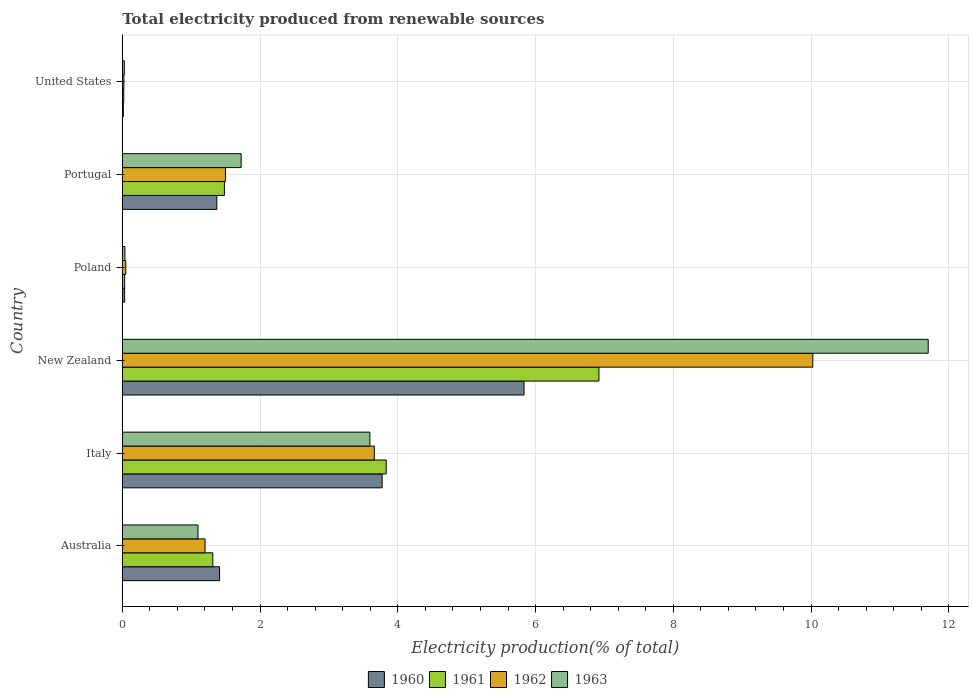How many groups of bars are there?
Offer a terse response. 6. Are the number of bars per tick equal to the number of legend labels?
Your answer should be very brief. Yes. Are the number of bars on each tick of the Y-axis equal?
Provide a short and direct response. Yes. How many bars are there on the 2nd tick from the top?
Your answer should be very brief. 4. In how many cases, is the number of bars for a given country not equal to the number of legend labels?
Your answer should be compact. 0. What is the total electricity produced in 1963 in Italy?
Provide a succinct answer. 3.59. Across all countries, what is the maximum total electricity produced in 1961?
Give a very brief answer. 6.92. Across all countries, what is the minimum total electricity produced in 1963?
Your answer should be very brief. 0.03. In which country was the total electricity produced in 1960 maximum?
Provide a succinct answer. New Zealand. In which country was the total electricity produced in 1960 minimum?
Ensure brevity in your answer.  United States. What is the total total electricity produced in 1963 in the graph?
Your response must be concise. 18.19. What is the difference between the total electricity produced in 1960 in New Zealand and that in Portugal?
Ensure brevity in your answer.  4.46. What is the difference between the total electricity produced in 1962 in Portugal and the total electricity produced in 1960 in New Zealand?
Keep it short and to the point. -4.33. What is the average total electricity produced in 1963 per country?
Your response must be concise. 3.03. What is the difference between the total electricity produced in 1960 and total electricity produced in 1961 in Portugal?
Provide a succinct answer. -0.11. In how many countries, is the total electricity produced in 1963 greater than 1.6 %?
Make the answer very short. 3. What is the ratio of the total electricity produced in 1961 in Australia to that in Poland?
Your answer should be compact. 38.51. Is the total electricity produced in 1961 in Australia less than that in New Zealand?
Your answer should be compact. Yes. What is the difference between the highest and the second highest total electricity produced in 1960?
Give a very brief answer. 2.06. What is the difference between the highest and the lowest total electricity produced in 1961?
Offer a very short reply. 6.9. In how many countries, is the total electricity produced in 1960 greater than the average total electricity produced in 1960 taken over all countries?
Your response must be concise. 2. Is it the case that in every country, the sum of the total electricity produced in 1961 and total electricity produced in 1962 is greater than the sum of total electricity produced in 1963 and total electricity produced in 1960?
Ensure brevity in your answer.  No. What does the 1st bar from the bottom in United States represents?
Your response must be concise. 1960. Is it the case that in every country, the sum of the total electricity produced in 1961 and total electricity produced in 1963 is greater than the total electricity produced in 1962?
Make the answer very short. Yes. What is the difference between two consecutive major ticks on the X-axis?
Provide a succinct answer. 2. Are the values on the major ticks of X-axis written in scientific E-notation?
Ensure brevity in your answer.  No. Does the graph contain any zero values?
Ensure brevity in your answer.  No. Where does the legend appear in the graph?
Keep it short and to the point. Bottom center. How many legend labels are there?
Offer a very short reply. 4. How are the legend labels stacked?
Make the answer very short. Horizontal. What is the title of the graph?
Provide a short and direct response. Total electricity produced from renewable sources. What is the Electricity production(% of total) of 1960 in Australia?
Offer a terse response. 1.41. What is the Electricity production(% of total) of 1961 in Australia?
Offer a very short reply. 1.31. What is the Electricity production(% of total) in 1962 in Australia?
Keep it short and to the point. 1.2. What is the Electricity production(% of total) of 1963 in Australia?
Offer a terse response. 1.1. What is the Electricity production(% of total) in 1960 in Italy?
Your response must be concise. 3.77. What is the Electricity production(% of total) in 1961 in Italy?
Provide a succinct answer. 3.83. What is the Electricity production(% of total) in 1962 in Italy?
Your answer should be compact. 3.66. What is the Electricity production(% of total) in 1963 in Italy?
Make the answer very short. 3.59. What is the Electricity production(% of total) in 1960 in New Zealand?
Keep it short and to the point. 5.83. What is the Electricity production(% of total) of 1961 in New Zealand?
Your answer should be compact. 6.92. What is the Electricity production(% of total) of 1962 in New Zealand?
Provide a short and direct response. 10.02. What is the Electricity production(% of total) in 1963 in New Zealand?
Ensure brevity in your answer.  11.7. What is the Electricity production(% of total) in 1960 in Poland?
Keep it short and to the point. 0.03. What is the Electricity production(% of total) of 1961 in Poland?
Keep it short and to the point. 0.03. What is the Electricity production(% of total) in 1962 in Poland?
Your answer should be compact. 0.05. What is the Electricity production(% of total) of 1963 in Poland?
Make the answer very short. 0.04. What is the Electricity production(% of total) in 1960 in Portugal?
Your answer should be very brief. 1.37. What is the Electricity production(% of total) in 1961 in Portugal?
Give a very brief answer. 1.48. What is the Electricity production(% of total) in 1962 in Portugal?
Provide a succinct answer. 1.5. What is the Electricity production(% of total) in 1963 in Portugal?
Make the answer very short. 1.73. What is the Electricity production(% of total) in 1960 in United States?
Keep it short and to the point. 0.02. What is the Electricity production(% of total) of 1961 in United States?
Make the answer very short. 0.02. What is the Electricity production(% of total) of 1962 in United States?
Make the answer very short. 0.02. What is the Electricity production(% of total) in 1963 in United States?
Provide a succinct answer. 0.03. Across all countries, what is the maximum Electricity production(% of total) in 1960?
Your response must be concise. 5.83. Across all countries, what is the maximum Electricity production(% of total) of 1961?
Give a very brief answer. 6.92. Across all countries, what is the maximum Electricity production(% of total) in 1962?
Your answer should be very brief. 10.02. Across all countries, what is the maximum Electricity production(% of total) of 1963?
Keep it short and to the point. 11.7. Across all countries, what is the minimum Electricity production(% of total) in 1960?
Provide a short and direct response. 0.02. Across all countries, what is the minimum Electricity production(% of total) in 1961?
Keep it short and to the point. 0.02. Across all countries, what is the minimum Electricity production(% of total) in 1962?
Offer a terse response. 0.02. Across all countries, what is the minimum Electricity production(% of total) of 1963?
Give a very brief answer. 0.03. What is the total Electricity production(% of total) of 1960 in the graph?
Offer a terse response. 12.44. What is the total Electricity production(% of total) in 1961 in the graph?
Make the answer very short. 13.6. What is the total Electricity production(% of total) of 1962 in the graph?
Your answer should be very brief. 16.46. What is the total Electricity production(% of total) in 1963 in the graph?
Keep it short and to the point. 18.19. What is the difference between the Electricity production(% of total) of 1960 in Australia and that in Italy?
Give a very brief answer. -2.36. What is the difference between the Electricity production(% of total) in 1961 in Australia and that in Italy?
Provide a short and direct response. -2.52. What is the difference between the Electricity production(% of total) of 1962 in Australia and that in Italy?
Your answer should be compact. -2.46. What is the difference between the Electricity production(% of total) in 1963 in Australia and that in Italy?
Provide a succinct answer. -2.5. What is the difference between the Electricity production(% of total) in 1960 in Australia and that in New Zealand?
Give a very brief answer. -4.42. What is the difference between the Electricity production(% of total) in 1961 in Australia and that in New Zealand?
Ensure brevity in your answer.  -5.61. What is the difference between the Electricity production(% of total) in 1962 in Australia and that in New Zealand?
Your answer should be very brief. -8.82. What is the difference between the Electricity production(% of total) of 1963 in Australia and that in New Zealand?
Your answer should be very brief. -10.6. What is the difference between the Electricity production(% of total) in 1960 in Australia and that in Poland?
Offer a terse response. 1.38. What is the difference between the Electricity production(% of total) in 1961 in Australia and that in Poland?
Ensure brevity in your answer.  1.28. What is the difference between the Electricity production(% of total) of 1962 in Australia and that in Poland?
Your answer should be very brief. 1.15. What is the difference between the Electricity production(% of total) in 1963 in Australia and that in Poland?
Offer a very short reply. 1.06. What is the difference between the Electricity production(% of total) in 1960 in Australia and that in Portugal?
Make the answer very short. 0.04. What is the difference between the Electricity production(% of total) of 1961 in Australia and that in Portugal?
Offer a very short reply. -0.17. What is the difference between the Electricity production(% of total) in 1962 in Australia and that in Portugal?
Provide a short and direct response. -0.3. What is the difference between the Electricity production(% of total) of 1963 in Australia and that in Portugal?
Ensure brevity in your answer.  -0.63. What is the difference between the Electricity production(% of total) in 1960 in Australia and that in United States?
Your answer should be compact. 1.4. What is the difference between the Electricity production(% of total) of 1961 in Australia and that in United States?
Your answer should be compact. 1.29. What is the difference between the Electricity production(% of total) in 1962 in Australia and that in United States?
Your answer should be compact. 1.18. What is the difference between the Electricity production(% of total) in 1963 in Australia and that in United States?
Provide a succinct answer. 1.07. What is the difference between the Electricity production(% of total) of 1960 in Italy and that in New Zealand?
Ensure brevity in your answer.  -2.06. What is the difference between the Electricity production(% of total) in 1961 in Italy and that in New Zealand?
Ensure brevity in your answer.  -3.09. What is the difference between the Electricity production(% of total) of 1962 in Italy and that in New Zealand?
Make the answer very short. -6.37. What is the difference between the Electricity production(% of total) of 1963 in Italy and that in New Zealand?
Make the answer very short. -8.11. What is the difference between the Electricity production(% of total) of 1960 in Italy and that in Poland?
Your response must be concise. 3.74. What is the difference between the Electricity production(% of total) in 1961 in Italy and that in Poland?
Keep it short and to the point. 3.8. What is the difference between the Electricity production(% of total) of 1962 in Italy and that in Poland?
Keep it short and to the point. 3.61. What is the difference between the Electricity production(% of total) of 1963 in Italy and that in Poland?
Provide a short and direct response. 3.56. What is the difference between the Electricity production(% of total) of 1960 in Italy and that in Portugal?
Ensure brevity in your answer.  2.4. What is the difference between the Electricity production(% of total) of 1961 in Italy and that in Portugal?
Provide a succinct answer. 2.35. What is the difference between the Electricity production(% of total) in 1962 in Italy and that in Portugal?
Offer a very short reply. 2.16. What is the difference between the Electricity production(% of total) of 1963 in Italy and that in Portugal?
Ensure brevity in your answer.  1.87. What is the difference between the Electricity production(% of total) in 1960 in Italy and that in United States?
Provide a succinct answer. 3.76. What is the difference between the Electricity production(% of total) of 1961 in Italy and that in United States?
Make the answer very short. 3.81. What is the difference between the Electricity production(% of total) in 1962 in Italy and that in United States?
Keep it short and to the point. 3.64. What is the difference between the Electricity production(% of total) of 1963 in Italy and that in United States?
Ensure brevity in your answer.  3.56. What is the difference between the Electricity production(% of total) of 1960 in New Zealand and that in Poland?
Keep it short and to the point. 5.8. What is the difference between the Electricity production(% of total) in 1961 in New Zealand and that in Poland?
Offer a very short reply. 6.89. What is the difference between the Electricity production(% of total) in 1962 in New Zealand and that in Poland?
Provide a succinct answer. 9.97. What is the difference between the Electricity production(% of total) of 1963 in New Zealand and that in Poland?
Your response must be concise. 11.66. What is the difference between the Electricity production(% of total) of 1960 in New Zealand and that in Portugal?
Your response must be concise. 4.46. What is the difference between the Electricity production(% of total) in 1961 in New Zealand and that in Portugal?
Make the answer very short. 5.44. What is the difference between the Electricity production(% of total) of 1962 in New Zealand and that in Portugal?
Offer a very short reply. 8.53. What is the difference between the Electricity production(% of total) in 1963 in New Zealand and that in Portugal?
Give a very brief answer. 9.97. What is the difference between the Electricity production(% of total) in 1960 in New Zealand and that in United States?
Provide a succinct answer. 5.82. What is the difference between the Electricity production(% of total) of 1961 in New Zealand and that in United States?
Ensure brevity in your answer.  6.9. What is the difference between the Electricity production(% of total) in 1962 in New Zealand and that in United States?
Your response must be concise. 10. What is the difference between the Electricity production(% of total) of 1963 in New Zealand and that in United States?
Offer a terse response. 11.67. What is the difference between the Electricity production(% of total) in 1960 in Poland and that in Portugal?
Make the answer very short. -1.34. What is the difference between the Electricity production(% of total) in 1961 in Poland and that in Portugal?
Provide a short and direct response. -1.45. What is the difference between the Electricity production(% of total) of 1962 in Poland and that in Portugal?
Keep it short and to the point. -1.45. What is the difference between the Electricity production(% of total) of 1963 in Poland and that in Portugal?
Your answer should be compact. -1.69. What is the difference between the Electricity production(% of total) of 1960 in Poland and that in United States?
Offer a terse response. 0.02. What is the difference between the Electricity production(% of total) in 1961 in Poland and that in United States?
Make the answer very short. 0.01. What is the difference between the Electricity production(% of total) of 1962 in Poland and that in United States?
Provide a succinct answer. 0.03. What is the difference between the Electricity production(% of total) of 1963 in Poland and that in United States?
Your answer should be compact. 0.01. What is the difference between the Electricity production(% of total) of 1960 in Portugal and that in United States?
Offer a very short reply. 1.36. What is the difference between the Electricity production(% of total) of 1961 in Portugal and that in United States?
Your answer should be compact. 1.46. What is the difference between the Electricity production(% of total) of 1962 in Portugal and that in United States?
Offer a terse response. 1.48. What is the difference between the Electricity production(% of total) in 1963 in Portugal and that in United States?
Make the answer very short. 1.7. What is the difference between the Electricity production(% of total) in 1960 in Australia and the Electricity production(% of total) in 1961 in Italy?
Provide a succinct answer. -2.42. What is the difference between the Electricity production(% of total) of 1960 in Australia and the Electricity production(% of total) of 1962 in Italy?
Provide a short and direct response. -2.25. What is the difference between the Electricity production(% of total) of 1960 in Australia and the Electricity production(% of total) of 1963 in Italy?
Your answer should be compact. -2.18. What is the difference between the Electricity production(% of total) of 1961 in Australia and the Electricity production(% of total) of 1962 in Italy?
Your response must be concise. -2.34. What is the difference between the Electricity production(% of total) in 1961 in Australia and the Electricity production(% of total) in 1963 in Italy?
Your answer should be compact. -2.28. What is the difference between the Electricity production(% of total) in 1962 in Australia and the Electricity production(% of total) in 1963 in Italy?
Your answer should be very brief. -2.39. What is the difference between the Electricity production(% of total) in 1960 in Australia and the Electricity production(% of total) in 1961 in New Zealand?
Offer a very short reply. -5.51. What is the difference between the Electricity production(% of total) in 1960 in Australia and the Electricity production(% of total) in 1962 in New Zealand?
Give a very brief answer. -8.61. What is the difference between the Electricity production(% of total) of 1960 in Australia and the Electricity production(% of total) of 1963 in New Zealand?
Offer a terse response. -10.29. What is the difference between the Electricity production(% of total) in 1961 in Australia and the Electricity production(% of total) in 1962 in New Zealand?
Offer a very short reply. -8.71. What is the difference between the Electricity production(% of total) of 1961 in Australia and the Electricity production(% of total) of 1963 in New Zealand?
Give a very brief answer. -10.39. What is the difference between the Electricity production(% of total) of 1962 in Australia and the Electricity production(% of total) of 1963 in New Zealand?
Provide a succinct answer. -10.5. What is the difference between the Electricity production(% of total) in 1960 in Australia and the Electricity production(% of total) in 1961 in Poland?
Provide a succinct answer. 1.38. What is the difference between the Electricity production(% of total) in 1960 in Australia and the Electricity production(% of total) in 1962 in Poland?
Provide a succinct answer. 1.36. What is the difference between the Electricity production(% of total) of 1960 in Australia and the Electricity production(% of total) of 1963 in Poland?
Provide a succinct answer. 1.37. What is the difference between the Electricity production(% of total) in 1961 in Australia and the Electricity production(% of total) in 1962 in Poland?
Give a very brief answer. 1.26. What is the difference between the Electricity production(% of total) of 1961 in Australia and the Electricity production(% of total) of 1963 in Poland?
Your answer should be very brief. 1.28. What is the difference between the Electricity production(% of total) of 1962 in Australia and the Electricity production(% of total) of 1963 in Poland?
Offer a terse response. 1.16. What is the difference between the Electricity production(% of total) in 1960 in Australia and the Electricity production(% of total) in 1961 in Portugal?
Offer a very short reply. -0.07. What is the difference between the Electricity production(% of total) in 1960 in Australia and the Electricity production(% of total) in 1962 in Portugal?
Keep it short and to the point. -0.09. What is the difference between the Electricity production(% of total) of 1960 in Australia and the Electricity production(% of total) of 1963 in Portugal?
Keep it short and to the point. -0.31. What is the difference between the Electricity production(% of total) of 1961 in Australia and the Electricity production(% of total) of 1962 in Portugal?
Offer a terse response. -0.18. What is the difference between the Electricity production(% of total) of 1961 in Australia and the Electricity production(% of total) of 1963 in Portugal?
Your answer should be very brief. -0.41. What is the difference between the Electricity production(% of total) in 1962 in Australia and the Electricity production(% of total) in 1963 in Portugal?
Offer a terse response. -0.52. What is the difference between the Electricity production(% of total) in 1960 in Australia and the Electricity production(% of total) in 1961 in United States?
Keep it short and to the point. 1.39. What is the difference between the Electricity production(% of total) in 1960 in Australia and the Electricity production(% of total) in 1962 in United States?
Offer a terse response. 1.39. What is the difference between the Electricity production(% of total) of 1960 in Australia and the Electricity production(% of total) of 1963 in United States?
Your answer should be compact. 1.38. What is the difference between the Electricity production(% of total) in 1961 in Australia and the Electricity production(% of total) in 1962 in United States?
Keep it short and to the point. 1.29. What is the difference between the Electricity production(% of total) of 1961 in Australia and the Electricity production(% of total) of 1963 in United States?
Make the answer very short. 1.28. What is the difference between the Electricity production(% of total) of 1962 in Australia and the Electricity production(% of total) of 1963 in United States?
Provide a short and direct response. 1.17. What is the difference between the Electricity production(% of total) of 1960 in Italy and the Electricity production(% of total) of 1961 in New Zealand?
Offer a terse response. -3.15. What is the difference between the Electricity production(% of total) in 1960 in Italy and the Electricity production(% of total) in 1962 in New Zealand?
Provide a succinct answer. -6.25. What is the difference between the Electricity production(% of total) in 1960 in Italy and the Electricity production(% of total) in 1963 in New Zealand?
Offer a very short reply. -7.93. What is the difference between the Electricity production(% of total) of 1961 in Italy and the Electricity production(% of total) of 1962 in New Zealand?
Your answer should be compact. -6.19. What is the difference between the Electricity production(% of total) of 1961 in Italy and the Electricity production(% of total) of 1963 in New Zealand?
Provide a succinct answer. -7.87. What is the difference between the Electricity production(% of total) in 1962 in Italy and the Electricity production(% of total) in 1963 in New Zealand?
Give a very brief answer. -8.04. What is the difference between the Electricity production(% of total) in 1960 in Italy and the Electricity production(% of total) in 1961 in Poland?
Make the answer very short. 3.74. What is the difference between the Electricity production(% of total) of 1960 in Italy and the Electricity production(% of total) of 1962 in Poland?
Ensure brevity in your answer.  3.72. What is the difference between the Electricity production(% of total) of 1960 in Italy and the Electricity production(% of total) of 1963 in Poland?
Offer a very short reply. 3.73. What is the difference between the Electricity production(% of total) in 1961 in Italy and the Electricity production(% of total) in 1962 in Poland?
Make the answer very short. 3.78. What is the difference between the Electricity production(% of total) of 1961 in Italy and the Electricity production(% of total) of 1963 in Poland?
Your answer should be very brief. 3.79. What is the difference between the Electricity production(% of total) in 1962 in Italy and the Electricity production(% of total) in 1963 in Poland?
Ensure brevity in your answer.  3.62. What is the difference between the Electricity production(% of total) of 1960 in Italy and the Electricity production(% of total) of 1961 in Portugal?
Ensure brevity in your answer.  2.29. What is the difference between the Electricity production(% of total) of 1960 in Italy and the Electricity production(% of total) of 1962 in Portugal?
Your response must be concise. 2.27. What is the difference between the Electricity production(% of total) in 1960 in Italy and the Electricity production(% of total) in 1963 in Portugal?
Keep it short and to the point. 2.05. What is the difference between the Electricity production(% of total) of 1961 in Italy and the Electricity production(% of total) of 1962 in Portugal?
Your answer should be very brief. 2.33. What is the difference between the Electricity production(% of total) of 1961 in Italy and the Electricity production(% of total) of 1963 in Portugal?
Ensure brevity in your answer.  2.11. What is the difference between the Electricity production(% of total) of 1962 in Italy and the Electricity production(% of total) of 1963 in Portugal?
Give a very brief answer. 1.93. What is the difference between the Electricity production(% of total) in 1960 in Italy and the Electricity production(% of total) in 1961 in United States?
Keep it short and to the point. 3.75. What is the difference between the Electricity production(% of total) in 1960 in Italy and the Electricity production(% of total) in 1962 in United States?
Ensure brevity in your answer.  3.75. What is the difference between the Electricity production(% of total) of 1960 in Italy and the Electricity production(% of total) of 1963 in United States?
Keep it short and to the point. 3.74. What is the difference between the Electricity production(% of total) of 1961 in Italy and the Electricity production(% of total) of 1962 in United States?
Ensure brevity in your answer.  3.81. What is the difference between the Electricity production(% of total) in 1961 in Italy and the Electricity production(% of total) in 1963 in United States?
Keep it short and to the point. 3.8. What is the difference between the Electricity production(% of total) in 1962 in Italy and the Electricity production(% of total) in 1963 in United States?
Offer a terse response. 3.63. What is the difference between the Electricity production(% of total) in 1960 in New Zealand and the Electricity production(% of total) in 1961 in Poland?
Your answer should be very brief. 5.8. What is the difference between the Electricity production(% of total) in 1960 in New Zealand and the Electricity production(% of total) in 1962 in Poland?
Offer a terse response. 5.78. What is the difference between the Electricity production(% of total) in 1960 in New Zealand and the Electricity production(% of total) in 1963 in Poland?
Provide a succinct answer. 5.79. What is the difference between the Electricity production(% of total) of 1961 in New Zealand and the Electricity production(% of total) of 1962 in Poland?
Your answer should be very brief. 6.87. What is the difference between the Electricity production(% of total) of 1961 in New Zealand and the Electricity production(% of total) of 1963 in Poland?
Your response must be concise. 6.88. What is the difference between the Electricity production(% of total) of 1962 in New Zealand and the Electricity production(% of total) of 1963 in Poland?
Keep it short and to the point. 9.99. What is the difference between the Electricity production(% of total) of 1960 in New Zealand and the Electricity production(% of total) of 1961 in Portugal?
Make the answer very short. 4.35. What is the difference between the Electricity production(% of total) in 1960 in New Zealand and the Electricity production(% of total) in 1962 in Portugal?
Your answer should be compact. 4.33. What is the difference between the Electricity production(% of total) in 1960 in New Zealand and the Electricity production(% of total) in 1963 in Portugal?
Provide a short and direct response. 4.11. What is the difference between the Electricity production(% of total) of 1961 in New Zealand and the Electricity production(% of total) of 1962 in Portugal?
Make the answer very short. 5.42. What is the difference between the Electricity production(% of total) in 1961 in New Zealand and the Electricity production(% of total) in 1963 in Portugal?
Offer a terse response. 5.19. What is the difference between the Electricity production(% of total) in 1962 in New Zealand and the Electricity production(% of total) in 1963 in Portugal?
Your answer should be compact. 8.3. What is the difference between the Electricity production(% of total) in 1960 in New Zealand and the Electricity production(% of total) in 1961 in United States?
Your answer should be very brief. 5.81. What is the difference between the Electricity production(% of total) in 1960 in New Zealand and the Electricity production(% of total) in 1962 in United States?
Offer a terse response. 5.81. What is the difference between the Electricity production(% of total) in 1960 in New Zealand and the Electricity production(% of total) in 1963 in United States?
Give a very brief answer. 5.8. What is the difference between the Electricity production(% of total) in 1961 in New Zealand and the Electricity production(% of total) in 1962 in United States?
Give a very brief answer. 6.9. What is the difference between the Electricity production(% of total) in 1961 in New Zealand and the Electricity production(% of total) in 1963 in United States?
Provide a succinct answer. 6.89. What is the difference between the Electricity production(% of total) of 1962 in New Zealand and the Electricity production(% of total) of 1963 in United States?
Give a very brief answer. 10. What is the difference between the Electricity production(% of total) in 1960 in Poland and the Electricity production(% of total) in 1961 in Portugal?
Keep it short and to the point. -1.45. What is the difference between the Electricity production(% of total) in 1960 in Poland and the Electricity production(% of total) in 1962 in Portugal?
Your response must be concise. -1.46. What is the difference between the Electricity production(% of total) of 1960 in Poland and the Electricity production(% of total) of 1963 in Portugal?
Your answer should be very brief. -1.69. What is the difference between the Electricity production(% of total) in 1961 in Poland and the Electricity production(% of total) in 1962 in Portugal?
Make the answer very short. -1.46. What is the difference between the Electricity production(% of total) in 1961 in Poland and the Electricity production(% of total) in 1963 in Portugal?
Offer a very short reply. -1.69. What is the difference between the Electricity production(% of total) of 1962 in Poland and the Electricity production(% of total) of 1963 in Portugal?
Provide a succinct answer. -1.67. What is the difference between the Electricity production(% of total) in 1960 in Poland and the Electricity production(% of total) in 1961 in United States?
Provide a short and direct response. 0.01. What is the difference between the Electricity production(% of total) of 1960 in Poland and the Electricity production(% of total) of 1962 in United States?
Keep it short and to the point. 0.01. What is the difference between the Electricity production(% of total) of 1960 in Poland and the Electricity production(% of total) of 1963 in United States?
Provide a short and direct response. 0. What is the difference between the Electricity production(% of total) of 1961 in Poland and the Electricity production(% of total) of 1962 in United States?
Ensure brevity in your answer.  0.01. What is the difference between the Electricity production(% of total) of 1961 in Poland and the Electricity production(% of total) of 1963 in United States?
Offer a very short reply. 0. What is the difference between the Electricity production(% of total) in 1962 in Poland and the Electricity production(% of total) in 1963 in United States?
Offer a terse response. 0.02. What is the difference between the Electricity production(% of total) of 1960 in Portugal and the Electricity production(% of total) of 1961 in United States?
Your answer should be very brief. 1.35. What is the difference between the Electricity production(% of total) of 1960 in Portugal and the Electricity production(% of total) of 1962 in United States?
Your response must be concise. 1.35. What is the difference between the Electricity production(% of total) in 1960 in Portugal and the Electricity production(% of total) in 1963 in United States?
Your response must be concise. 1.34. What is the difference between the Electricity production(% of total) of 1961 in Portugal and the Electricity production(% of total) of 1962 in United States?
Keep it short and to the point. 1.46. What is the difference between the Electricity production(% of total) in 1961 in Portugal and the Electricity production(% of total) in 1963 in United States?
Keep it short and to the point. 1.45. What is the difference between the Electricity production(% of total) in 1962 in Portugal and the Electricity production(% of total) in 1963 in United States?
Provide a succinct answer. 1.47. What is the average Electricity production(% of total) in 1960 per country?
Provide a succinct answer. 2.07. What is the average Electricity production(% of total) of 1961 per country?
Give a very brief answer. 2.27. What is the average Electricity production(% of total) in 1962 per country?
Your answer should be compact. 2.74. What is the average Electricity production(% of total) of 1963 per country?
Offer a terse response. 3.03. What is the difference between the Electricity production(% of total) of 1960 and Electricity production(% of total) of 1961 in Australia?
Your response must be concise. 0.1. What is the difference between the Electricity production(% of total) of 1960 and Electricity production(% of total) of 1962 in Australia?
Give a very brief answer. 0.21. What is the difference between the Electricity production(% of total) in 1960 and Electricity production(% of total) in 1963 in Australia?
Provide a short and direct response. 0.31. What is the difference between the Electricity production(% of total) in 1961 and Electricity production(% of total) in 1962 in Australia?
Your response must be concise. 0.11. What is the difference between the Electricity production(% of total) of 1961 and Electricity production(% of total) of 1963 in Australia?
Your answer should be compact. 0.21. What is the difference between the Electricity production(% of total) of 1962 and Electricity production(% of total) of 1963 in Australia?
Make the answer very short. 0.1. What is the difference between the Electricity production(% of total) in 1960 and Electricity production(% of total) in 1961 in Italy?
Offer a very short reply. -0.06. What is the difference between the Electricity production(% of total) of 1960 and Electricity production(% of total) of 1962 in Italy?
Give a very brief answer. 0.11. What is the difference between the Electricity production(% of total) of 1960 and Electricity production(% of total) of 1963 in Italy?
Ensure brevity in your answer.  0.18. What is the difference between the Electricity production(% of total) of 1961 and Electricity production(% of total) of 1962 in Italy?
Keep it short and to the point. 0.17. What is the difference between the Electricity production(% of total) of 1961 and Electricity production(% of total) of 1963 in Italy?
Keep it short and to the point. 0.24. What is the difference between the Electricity production(% of total) of 1962 and Electricity production(% of total) of 1963 in Italy?
Offer a terse response. 0.06. What is the difference between the Electricity production(% of total) of 1960 and Electricity production(% of total) of 1961 in New Zealand?
Make the answer very short. -1.09. What is the difference between the Electricity production(% of total) of 1960 and Electricity production(% of total) of 1962 in New Zealand?
Your response must be concise. -4.19. What is the difference between the Electricity production(% of total) of 1960 and Electricity production(% of total) of 1963 in New Zealand?
Give a very brief answer. -5.87. What is the difference between the Electricity production(% of total) in 1961 and Electricity production(% of total) in 1962 in New Zealand?
Provide a succinct answer. -3.1. What is the difference between the Electricity production(% of total) of 1961 and Electricity production(% of total) of 1963 in New Zealand?
Provide a succinct answer. -4.78. What is the difference between the Electricity production(% of total) in 1962 and Electricity production(% of total) in 1963 in New Zealand?
Your response must be concise. -1.68. What is the difference between the Electricity production(% of total) of 1960 and Electricity production(% of total) of 1962 in Poland?
Your response must be concise. -0.02. What is the difference between the Electricity production(% of total) of 1960 and Electricity production(% of total) of 1963 in Poland?
Give a very brief answer. -0. What is the difference between the Electricity production(% of total) in 1961 and Electricity production(% of total) in 1962 in Poland?
Provide a short and direct response. -0.02. What is the difference between the Electricity production(% of total) in 1961 and Electricity production(% of total) in 1963 in Poland?
Provide a short and direct response. -0. What is the difference between the Electricity production(% of total) of 1962 and Electricity production(% of total) of 1963 in Poland?
Ensure brevity in your answer.  0.01. What is the difference between the Electricity production(% of total) of 1960 and Electricity production(% of total) of 1961 in Portugal?
Provide a short and direct response. -0.11. What is the difference between the Electricity production(% of total) of 1960 and Electricity production(% of total) of 1962 in Portugal?
Offer a terse response. -0.13. What is the difference between the Electricity production(% of total) of 1960 and Electricity production(% of total) of 1963 in Portugal?
Make the answer very short. -0.35. What is the difference between the Electricity production(% of total) of 1961 and Electricity production(% of total) of 1962 in Portugal?
Make the answer very short. -0.02. What is the difference between the Electricity production(% of total) in 1961 and Electricity production(% of total) in 1963 in Portugal?
Provide a short and direct response. -0.24. What is the difference between the Electricity production(% of total) of 1962 and Electricity production(% of total) of 1963 in Portugal?
Provide a short and direct response. -0.23. What is the difference between the Electricity production(% of total) of 1960 and Electricity production(% of total) of 1961 in United States?
Offer a terse response. -0.01. What is the difference between the Electricity production(% of total) of 1960 and Electricity production(% of total) of 1962 in United States?
Provide a short and direct response. -0.01. What is the difference between the Electricity production(% of total) of 1960 and Electricity production(% of total) of 1963 in United States?
Offer a very short reply. -0.01. What is the difference between the Electricity production(% of total) in 1961 and Electricity production(% of total) in 1962 in United States?
Offer a terse response. -0. What is the difference between the Electricity production(% of total) of 1961 and Electricity production(% of total) of 1963 in United States?
Make the answer very short. -0.01. What is the difference between the Electricity production(% of total) in 1962 and Electricity production(% of total) in 1963 in United States?
Keep it short and to the point. -0.01. What is the ratio of the Electricity production(% of total) of 1960 in Australia to that in Italy?
Ensure brevity in your answer.  0.37. What is the ratio of the Electricity production(% of total) of 1961 in Australia to that in Italy?
Your answer should be very brief. 0.34. What is the ratio of the Electricity production(% of total) in 1962 in Australia to that in Italy?
Provide a short and direct response. 0.33. What is the ratio of the Electricity production(% of total) of 1963 in Australia to that in Italy?
Offer a terse response. 0.31. What is the ratio of the Electricity production(% of total) of 1960 in Australia to that in New Zealand?
Your answer should be compact. 0.24. What is the ratio of the Electricity production(% of total) in 1961 in Australia to that in New Zealand?
Provide a short and direct response. 0.19. What is the ratio of the Electricity production(% of total) of 1962 in Australia to that in New Zealand?
Your answer should be very brief. 0.12. What is the ratio of the Electricity production(% of total) of 1963 in Australia to that in New Zealand?
Provide a short and direct response. 0.09. What is the ratio of the Electricity production(% of total) in 1960 in Australia to that in Poland?
Provide a succinct answer. 41.37. What is the ratio of the Electricity production(% of total) of 1961 in Australia to that in Poland?
Give a very brief answer. 38.51. What is the ratio of the Electricity production(% of total) of 1962 in Australia to that in Poland?
Make the answer very short. 23.61. What is the ratio of the Electricity production(% of total) in 1963 in Australia to that in Poland?
Your answer should be compact. 29. What is the ratio of the Electricity production(% of total) of 1960 in Australia to that in Portugal?
Give a very brief answer. 1.03. What is the ratio of the Electricity production(% of total) in 1961 in Australia to that in Portugal?
Your answer should be very brief. 0.89. What is the ratio of the Electricity production(% of total) of 1962 in Australia to that in Portugal?
Your response must be concise. 0.8. What is the ratio of the Electricity production(% of total) in 1963 in Australia to that in Portugal?
Provide a succinct answer. 0.64. What is the ratio of the Electricity production(% of total) of 1960 in Australia to that in United States?
Offer a terse response. 92.6. What is the ratio of the Electricity production(% of total) of 1961 in Australia to that in United States?
Ensure brevity in your answer.  61. What is the ratio of the Electricity production(% of total) in 1962 in Australia to that in United States?
Provide a short and direct response. 52.74. What is the ratio of the Electricity production(% of total) in 1963 in Australia to that in United States?
Keep it short and to the point. 37.34. What is the ratio of the Electricity production(% of total) in 1960 in Italy to that in New Zealand?
Offer a terse response. 0.65. What is the ratio of the Electricity production(% of total) of 1961 in Italy to that in New Zealand?
Your answer should be compact. 0.55. What is the ratio of the Electricity production(% of total) in 1962 in Italy to that in New Zealand?
Offer a very short reply. 0.36. What is the ratio of the Electricity production(% of total) in 1963 in Italy to that in New Zealand?
Your answer should be very brief. 0.31. What is the ratio of the Electricity production(% of total) of 1960 in Italy to that in Poland?
Your answer should be compact. 110.45. What is the ratio of the Electricity production(% of total) of 1961 in Italy to that in Poland?
Your response must be concise. 112.3. What is the ratio of the Electricity production(% of total) of 1962 in Italy to that in Poland?
Make the answer very short. 71.88. What is the ratio of the Electricity production(% of total) of 1963 in Italy to that in Poland?
Provide a succinct answer. 94.84. What is the ratio of the Electricity production(% of total) of 1960 in Italy to that in Portugal?
Offer a very short reply. 2.75. What is the ratio of the Electricity production(% of total) in 1961 in Italy to that in Portugal?
Provide a short and direct response. 2.58. What is the ratio of the Electricity production(% of total) of 1962 in Italy to that in Portugal?
Provide a short and direct response. 2.44. What is the ratio of the Electricity production(% of total) of 1963 in Italy to that in Portugal?
Your response must be concise. 2.08. What is the ratio of the Electricity production(% of total) of 1960 in Italy to that in United States?
Your answer should be very brief. 247.25. What is the ratio of the Electricity production(% of total) of 1961 in Italy to that in United States?
Your answer should be very brief. 177.87. What is the ratio of the Electricity production(% of total) in 1962 in Italy to that in United States?
Give a very brief answer. 160.56. What is the ratio of the Electricity production(% of total) in 1963 in Italy to that in United States?
Ensure brevity in your answer.  122.12. What is the ratio of the Electricity production(% of total) of 1960 in New Zealand to that in Poland?
Make the answer very short. 170.79. What is the ratio of the Electricity production(% of total) of 1961 in New Zealand to that in Poland?
Provide a short and direct response. 202.83. What is the ratio of the Electricity production(% of total) of 1962 in New Zealand to that in Poland?
Give a very brief answer. 196.95. What is the ratio of the Electricity production(% of total) in 1963 in New Zealand to that in Poland?
Your answer should be very brief. 308.73. What is the ratio of the Electricity production(% of total) in 1960 in New Zealand to that in Portugal?
Make the answer very short. 4.25. What is the ratio of the Electricity production(% of total) of 1961 in New Zealand to that in Portugal?
Your answer should be compact. 4.67. What is the ratio of the Electricity production(% of total) in 1962 in New Zealand to that in Portugal?
Provide a short and direct response. 6.69. What is the ratio of the Electricity production(% of total) in 1963 in New Zealand to that in Portugal?
Ensure brevity in your answer.  6.78. What is the ratio of the Electricity production(% of total) of 1960 in New Zealand to that in United States?
Your response must be concise. 382.31. What is the ratio of the Electricity production(% of total) in 1961 in New Zealand to that in United States?
Give a very brief answer. 321.25. What is the ratio of the Electricity production(% of total) of 1962 in New Zealand to that in United States?
Your answer should be compact. 439.93. What is the ratio of the Electricity production(% of total) in 1963 in New Zealand to that in United States?
Your response must be concise. 397.5. What is the ratio of the Electricity production(% of total) of 1960 in Poland to that in Portugal?
Your answer should be very brief. 0.02. What is the ratio of the Electricity production(% of total) of 1961 in Poland to that in Portugal?
Provide a succinct answer. 0.02. What is the ratio of the Electricity production(% of total) of 1962 in Poland to that in Portugal?
Your answer should be very brief. 0.03. What is the ratio of the Electricity production(% of total) in 1963 in Poland to that in Portugal?
Your response must be concise. 0.02. What is the ratio of the Electricity production(% of total) in 1960 in Poland to that in United States?
Provide a succinct answer. 2.24. What is the ratio of the Electricity production(% of total) of 1961 in Poland to that in United States?
Ensure brevity in your answer.  1.58. What is the ratio of the Electricity production(% of total) in 1962 in Poland to that in United States?
Offer a terse response. 2.23. What is the ratio of the Electricity production(% of total) in 1963 in Poland to that in United States?
Make the answer very short. 1.29. What is the ratio of the Electricity production(% of total) in 1960 in Portugal to that in United States?
Offer a terse response. 89.96. What is the ratio of the Electricity production(% of total) of 1961 in Portugal to that in United States?
Your answer should be very brief. 68.83. What is the ratio of the Electricity production(% of total) in 1962 in Portugal to that in United States?
Give a very brief answer. 65.74. What is the ratio of the Electricity production(% of total) in 1963 in Portugal to that in United States?
Provide a succinct answer. 58.63. What is the difference between the highest and the second highest Electricity production(% of total) of 1960?
Make the answer very short. 2.06. What is the difference between the highest and the second highest Electricity production(% of total) of 1961?
Your response must be concise. 3.09. What is the difference between the highest and the second highest Electricity production(% of total) in 1962?
Provide a short and direct response. 6.37. What is the difference between the highest and the second highest Electricity production(% of total) in 1963?
Give a very brief answer. 8.11. What is the difference between the highest and the lowest Electricity production(% of total) in 1960?
Make the answer very short. 5.82. What is the difference between the highest and the lowest Electricity production(% of total) in 1961?
Your response must be concise. 6.9. What is the difference between the highest and the lowest Electricity production(% of total) in 1962?
Provide a succinct answer. 10. What is the difference between the highest and the lowest Electricity production(% of total) in 1963?
Provide a succinct answer. 11.67. 